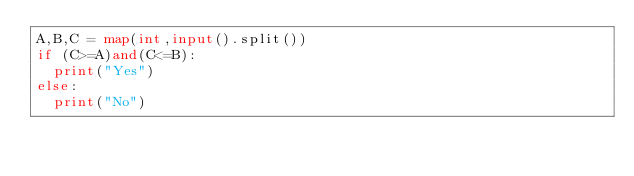<code> <loc_0><loc_0><loc_500><loc_500><_Python_>A,B,C = map(int,input().split())
if (C>=A)and(C<=B):
  print("Yes")
else:
  print("No")</code> 